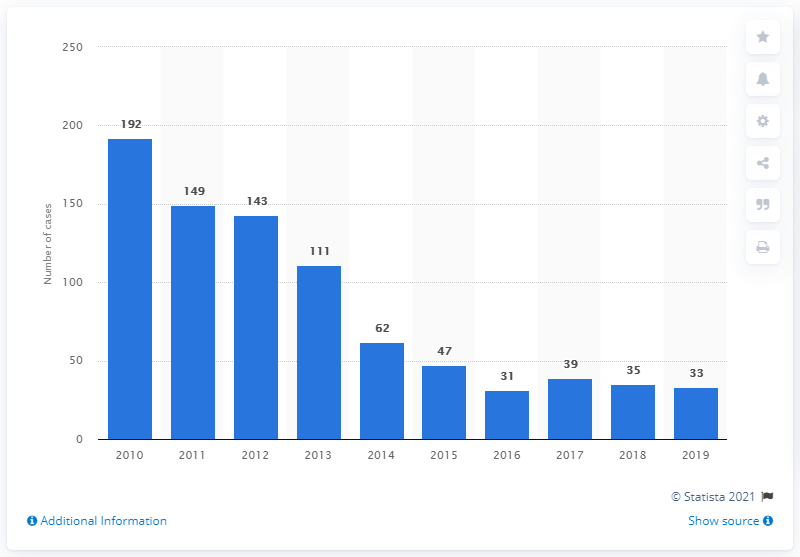What does the trend in the graph suggest about malaria cases in Singapore over the past decade? The bar graph illustrates a general decline in malaria cases in Singapore from 2010 to 2019. This suggests an improvement in malaria control and prevention measures over the years. 